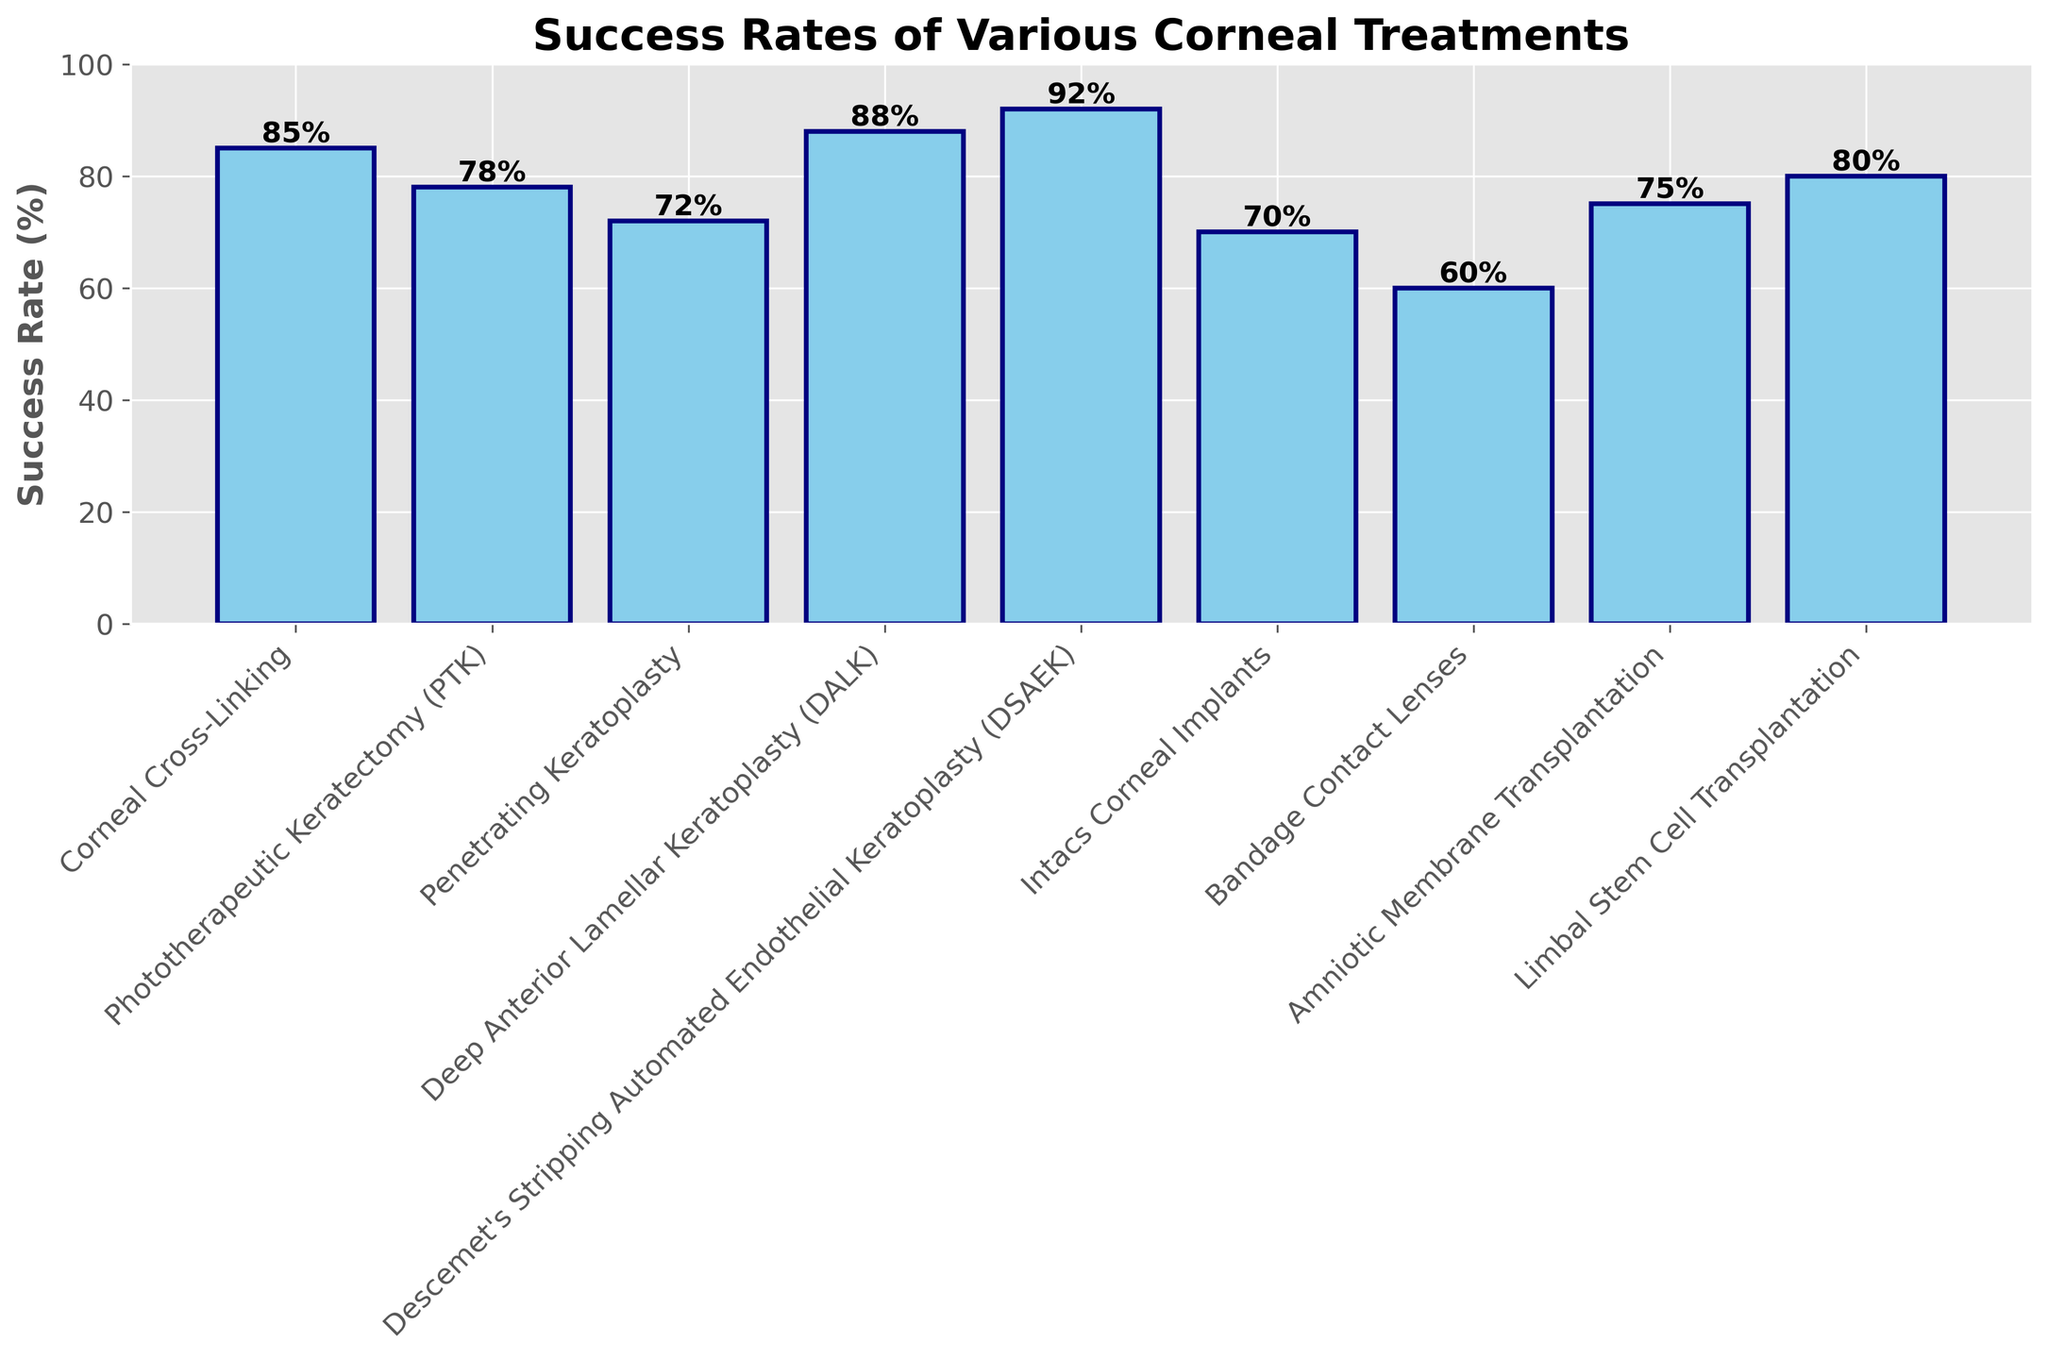Which treatment has the highest success rate? The bar for Descemet's Stripping Automated Endothelial Keratoplasty (DSAEK) reaches the highest point on the success rate axis.
Answer: Descemet's Stripping Automated Endothelial Keratoplasty (DSAEK) Which treatment has the lowest success rate? The bar for Bandage Contact Lenses is the shortest, indicating the lowest success rate.
Answer: Bandage Contact Lenses Compare the success rates of Corneal Cross-Linking and Phototherapeutic Keratectomy (PTK). Which one is higher and by how much? Corneal Cross-Linking has a success rate of 85%, while Phototherapeutic Keratectomy (PTK) has a success rate of 78%. The difference is 85% - 78% = 7%.
Answer: Corneal Cross-Linking by 7% Which treatments have a success rate higher than 80%? The treatments with success rates above the 80% mark are Corneal Cross-Linking, Deep Anterior Lamellar Keratoplasty (DALK), Descemet's Stripping Automated Endothelial Keratoplasty (DSAEK), and Limbal Stem Cell Transplantation.
Answer: Corneal Cross-Linking, Deep Anterior Lamellar Keratoplasty (DALK), Descemet's Stripping Automated Endothelial Keratoplasty (DSAEK), Limbal Stem Cell Transplantation What is the average success rate of all treatments? Sum all the success rates: 85 + 78 + 72 + 88 + 92 + 70 + 60 + 75 + 80 = 700. Dividing by the number of treatments (9) gives an average of 700 / 9 ≈ 77.78%.
Answer: 77.78% Which treatment has a success rate closest to the average success rate of all treatments? The average success rate is approximately 77.78%. Amniotic Membrane Transplantation at 75% is the closest to this average.
Answer: Amniotic Membrane Transplantation How many treatments have a success rate between 70% and 80%? The treatments that fall within this range are Phototherapeutic Keratectomy (PTK) at 78%, Penetrating Keratoplasty at 72%, Intacs Corneal Implants at 70%, Amniotic Membrane Transplantation at 75%, and Limbal Stem Cell Transplantation at 80%. There are 5 treatments in total.
Answer: 5 What is the difference in success rates between the highest and lowest treatments? The highest success rate is 92% (Descemet's Stripping Automated Endothelial Keratoplasty) and the lowest is 60% (Bandage Contact Lenses). The difference is 92% - 60% = 32%.
Answer: 32% Is the success rate of Penetrating Keratoplasty higher or lower than that of Deep Anterior Lamellar Keratoplasty (DALK)? By how much? Deep Anterior Lamellar Keratoplasty (DALK) has a success rate of 88%, and Penetrating Keratoplasty has a success rate of 72%. The difference is 88% - 72% = 16%, with DALK being higher.
Answer: Higher by 16% 